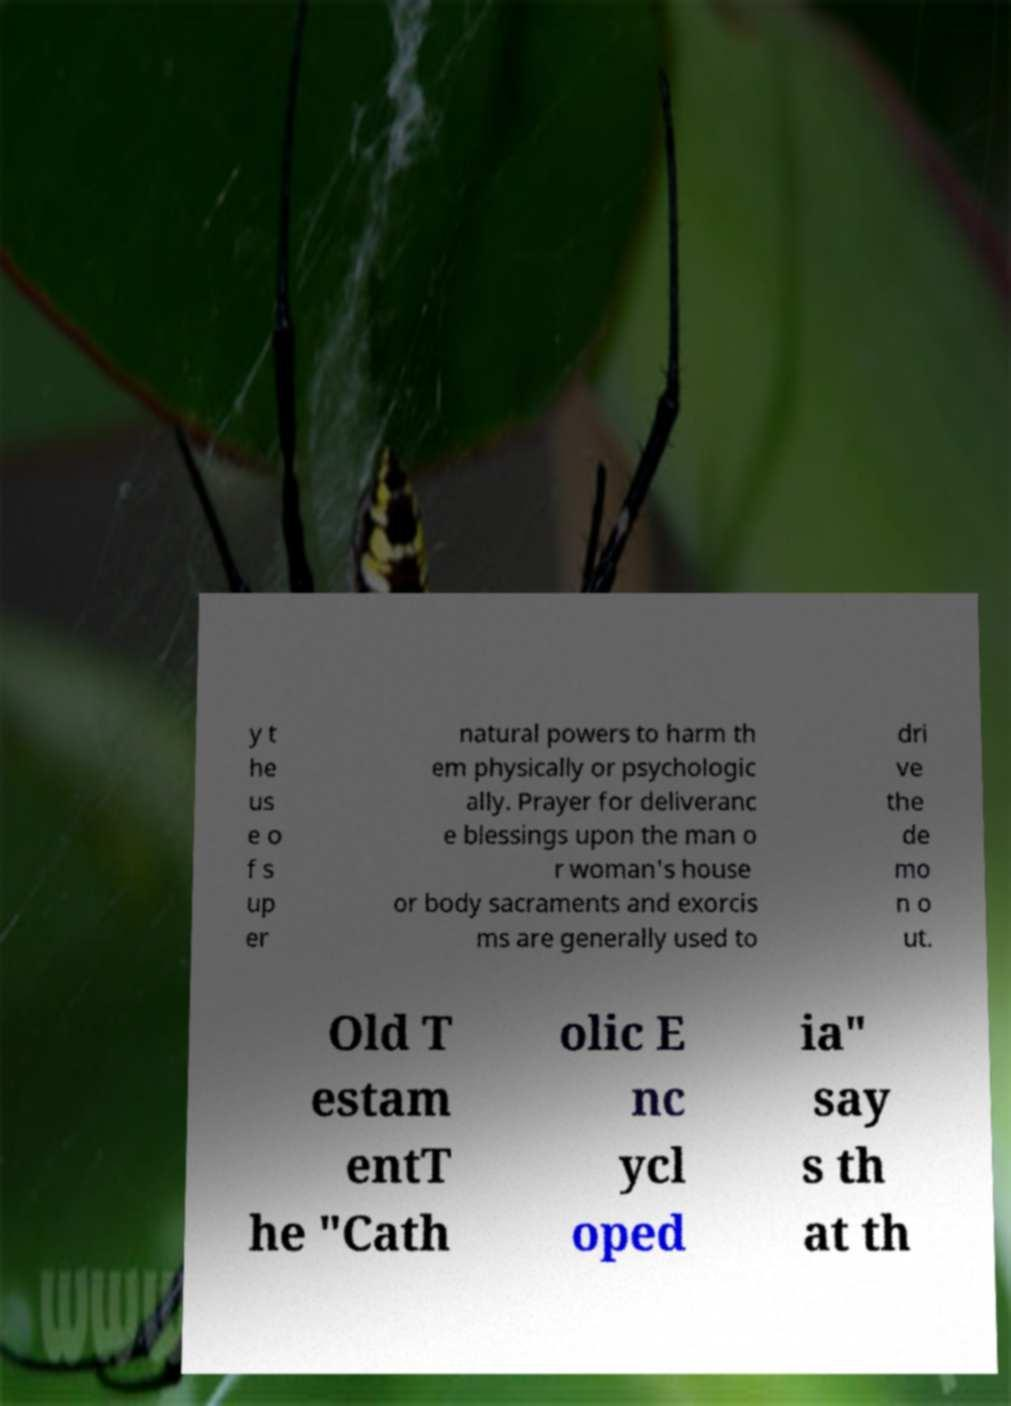There's text embedded in this image that I need extracted. Can you transcribe it verbatim? y t he us e o f s up er natural powers to harm th em physically or psychologic ally. Prayer for deliveranc e blessings upon the man o r woman's house or body sacraments and exorcis ms are generally used to dri ve the de mo n o ut. Old T estam entT he "Cath olic E nc ycl oped ia" say s th at th 